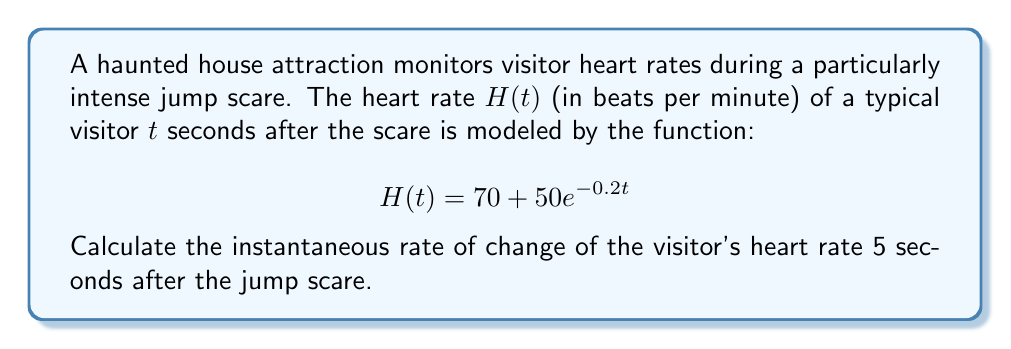Could you help me with this problem? To find the instantaneous rate of change of the heart rate, we need to calculate the derivative of $H(t)$ and evaluate it at $t=5$.

Step 1: Find the derivative of $H(t)$
$$\frac{d}{dt}H(t) = \frac{d}{dt}(70 + 50e^{-0.2t})$$
$$H'(t) = 0 + 50(-0.2)e^{-0.2t}$$
$$H'(t) = -10e^{-0.2t}$$

Step 2: Evaluate $H'(t)$ at $t=5$
$$H'(5) = -10e^{-0.2(5)}$$
$$H'(5) = -10e^{-1}$$
$$H'(5) \approx -3.68$$

Step 3: Interpret the result
The negative value indicates that the heart rate is decreasing. The rate of change is approximately -3.68 beats per minute per second at $t=5$ seconds after the jump scare.
Answer: $-3.68$ beats per minute per second 